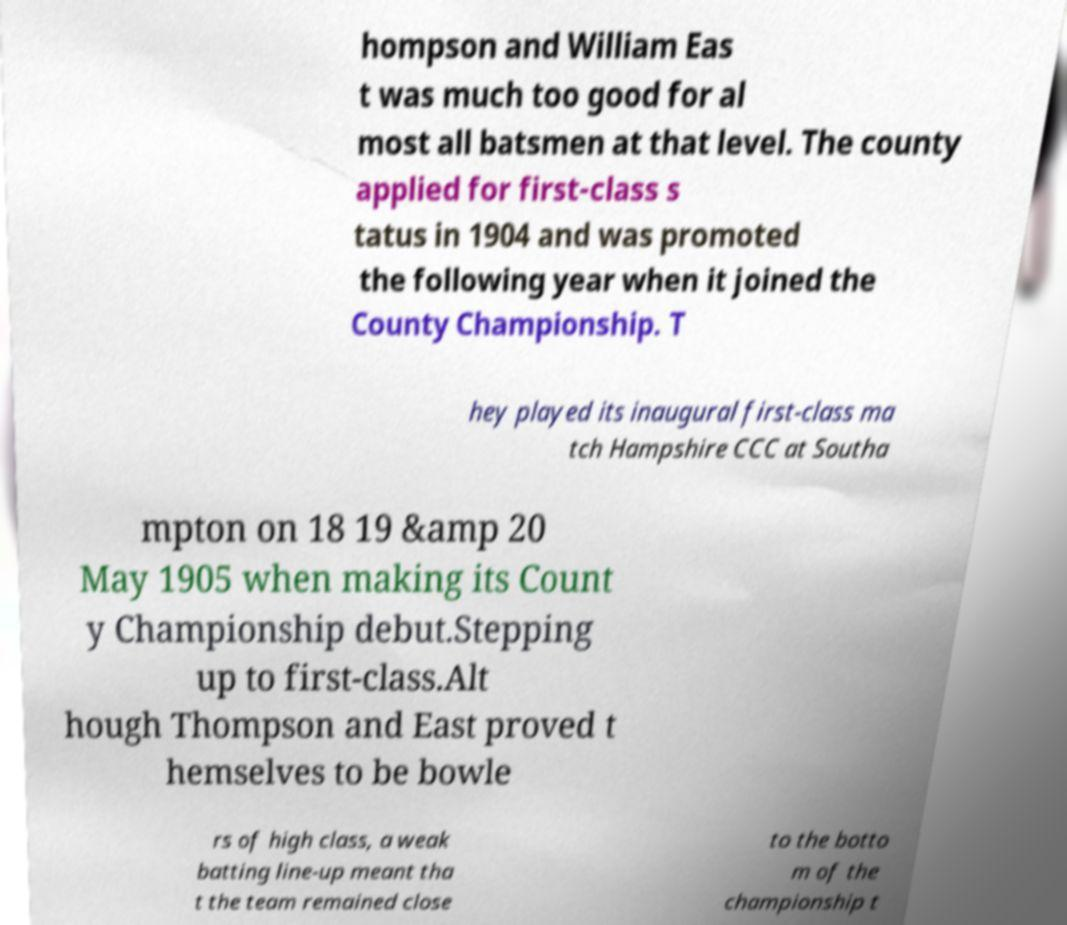I need the written content from this picture converted into text. Can you do that? hompson and William Eas t was much too good for al most all batsmen at that level. The county applied for first-class s tatus in 1904 and was promoted the following year when it joined the County Championship. T hey played its inaugural first-class ma tch Hampshire CCC at Southa mpton on 18 19 &amp 20 May 1905 when making its Count y Championship debut.Stepping up to first-class.Alt hough Thompson and East proved t hemselves to be bowle rs of high class, a weak batting line-up meant tha t the team remained close to the botto m of the championship t 